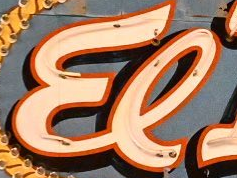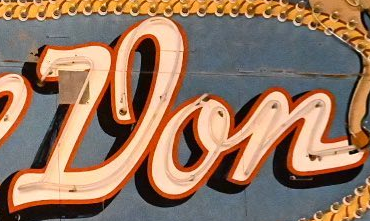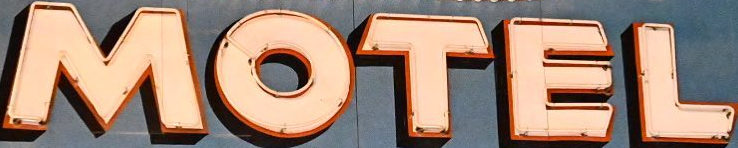What words can you see in these images in sequence, separated by a semicolon? El; Don; MOTEL 